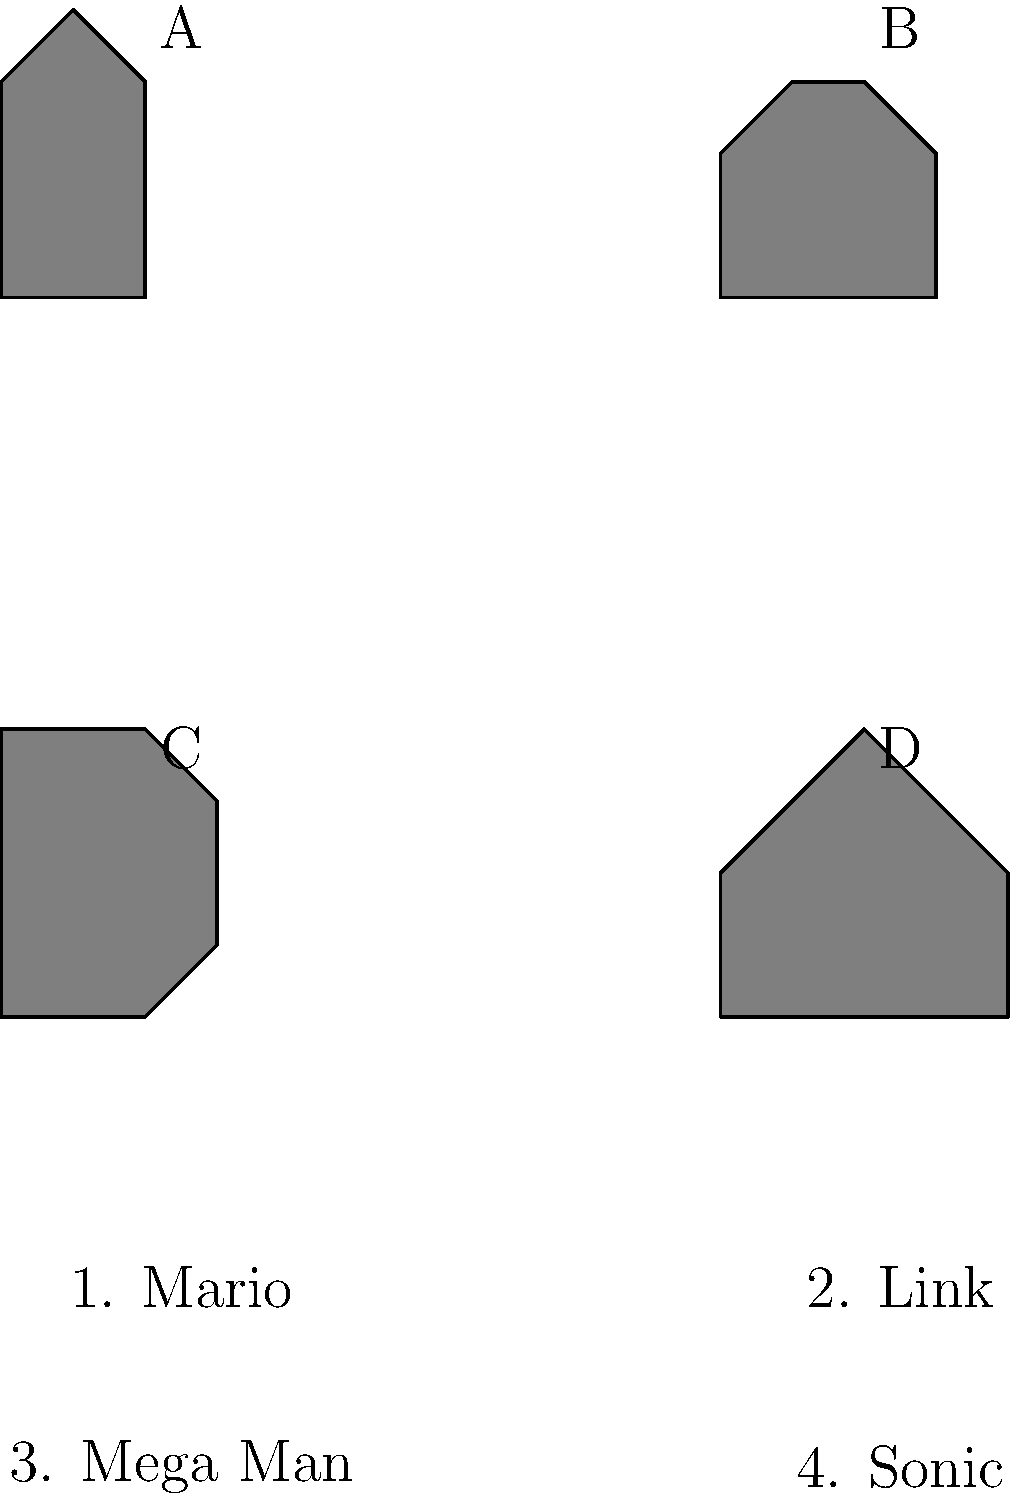Match the video game character silhouettes (A, B, C, D) to their corresponding names (1, 2, 3, 4). Which combination is correct? To solve this puzzle, we need to analyze each silhouette and match it to the corresponding character based on their iconic features:

1. Silhouette A: This shape has a rounded head with a cap, a plump body, and short limbs. This matches Mario's iconic appearance.

2. Silhouette B: This shape has a more angular head with pointed ears, suggesting Link's characteristic hat and elf-like features.

3. Silhouette C: This silhouette has a distinct helmet shape with a rounded body, matching Mega Man's robotic appearance.

4. Silhouette D: This shape has spikes on the head and a sleek body, clearly representing Sonic's quills and speedy design.

Therefore, the correct matching is:
A - 1 (Mario)
B - 2 (Link)
C - 3 (Mega Man)
D - 4 (Sonic)
Answer: A1, B2, C3, D4 